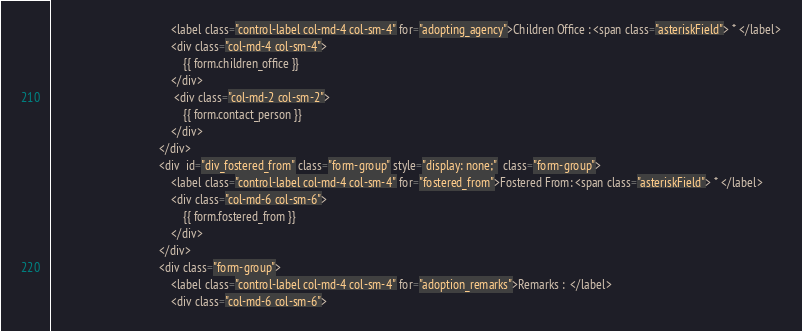<code> <loc_0><loc_0><loc_500><loc_500><_HTML_>                                        <label class="control-label col-md-4 col-sm-4" for="adopting_agency">Children Office : <span class="asteriskField"> * </label>
                                        <div class="col-md-4 col-sm-4">
                                            {{ form.children_office }}
                                        </div>
                                         <div class="col-md-2 col-sm-2">
                                            {{ form.contact_person }}
                                        </div>
                                    </div>
                                    <div  id="div_fostered_from" class="form-group" style="display: none;"  class="form-group">
                                        <label class="control-label col-md-4 col-sm-4" for="fostered_from">Fostered From: <span class="asteriskField"> * </label>
                                        <div class="col-md-6 col-sm-6">
                                            {{ form.fostered_from }}
                                        </div>
                                    </div>
                                    <div class="form-group">
                                        <label class="control-label col-md-4 col-sm-4" for="adoption_remarks">Remarks :  </label>
                                        <div class="col-md-6 col-sm-6"></code> 